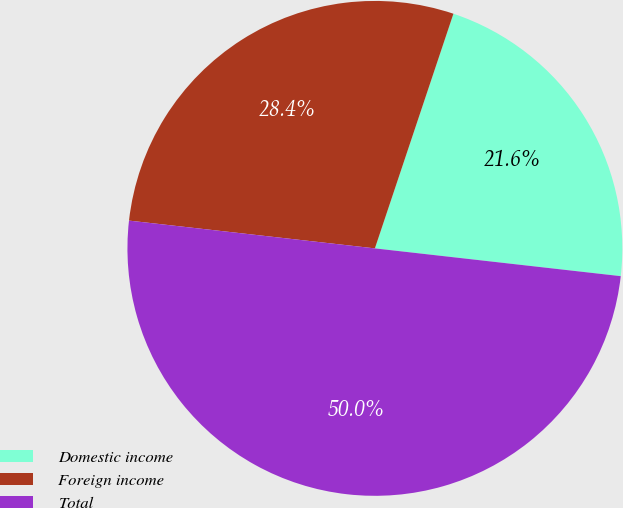<chart> <loc_0><loc_0><loc_500><loc_500><pie_chart><fcel>Domestic income<fcel>Foreign income<fcel>Total<nl><fcel>21.65%<fcel>28.35%<fcel>50.0%<nl></chart> 